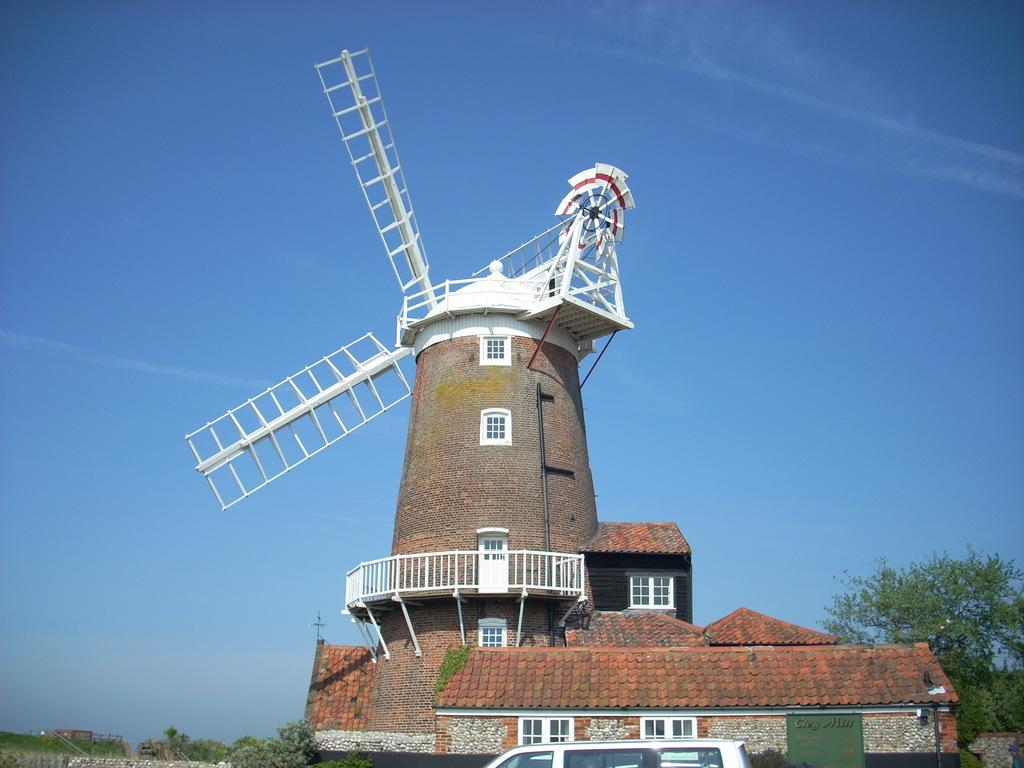What is the main subject in the picture? There is a windmill in the picture. What is located in front of the windmill? There is a vehicle in front of the windmill. What can be seen in the background of the picture? There are trees in the background of the picture. What type of alarm system is installed in the windmill? There is no mention of an alarm system in the image, as it features a windmill, a vehicle, and trees in the background. 